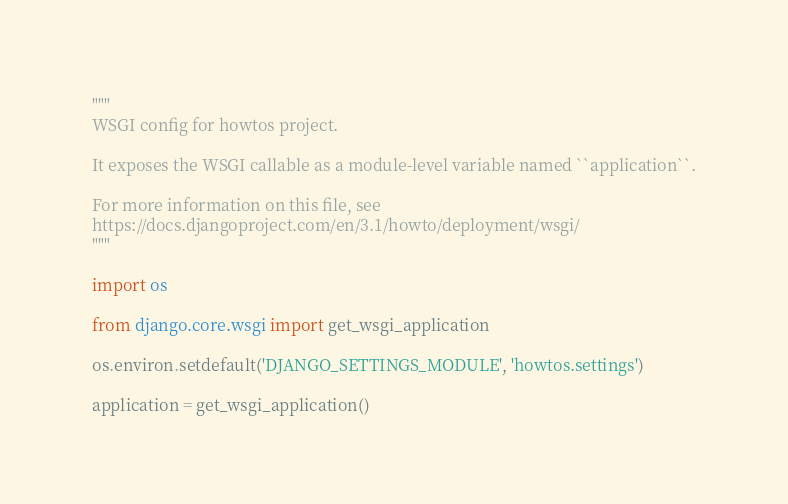<code> <loc_0><loc_0><loc_500><loc_500><_Python_>"""
WSGI config for howtos project.

It exposes the WSGI callable as a module-level variable named ``application``.

For more information on this file, see
https://docs.djangoproject.com/en/3.1/howto/deployment/wsgi/
"""

import os

from django.core.wsgi import get_wsgi_application

os.environ.setdefault('DJANGO_SETTINGS_MODULE', 'howtos.settings')

application = get_wsgi_application()
</code> 